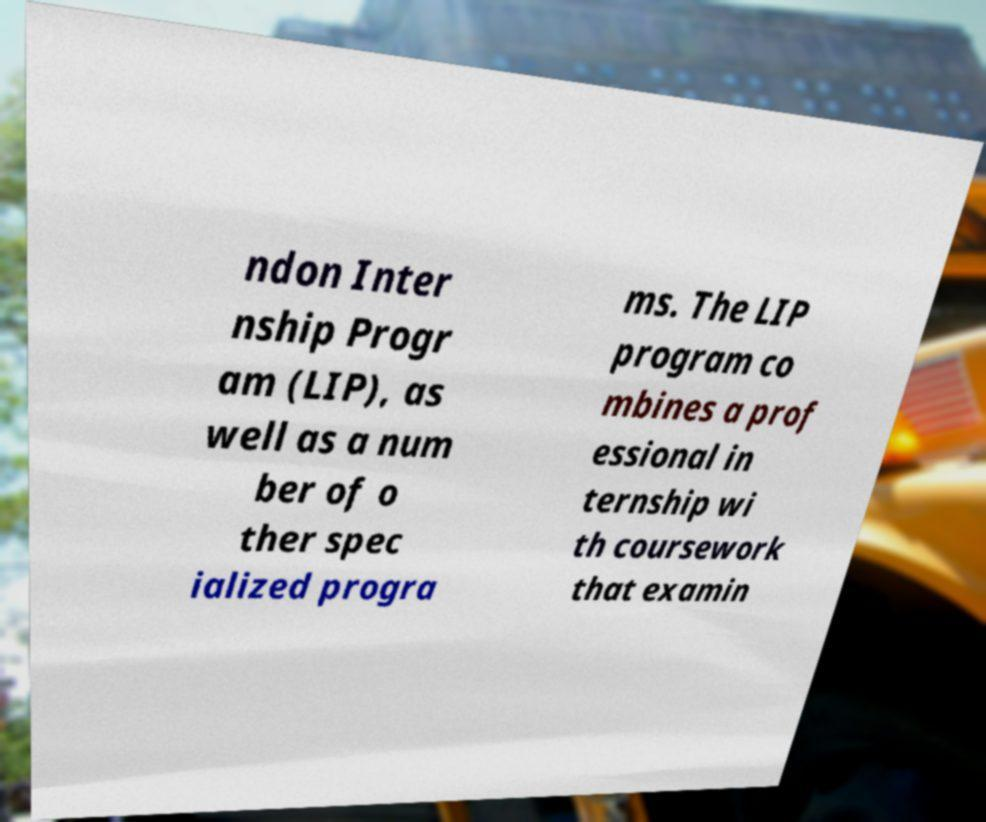Could you assist in decoding the text presented in this image and type it out clearly? ndon Inter nship Progr am (LIP), as well as a num ber of o ther spec ialized progra ms. The LIP program co mbines a prof essional in ternship wi th coursework that examin 